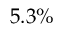<formula> <loc_0><loc_0><loc_500><loc_500>5 . 3 \%</formula> 